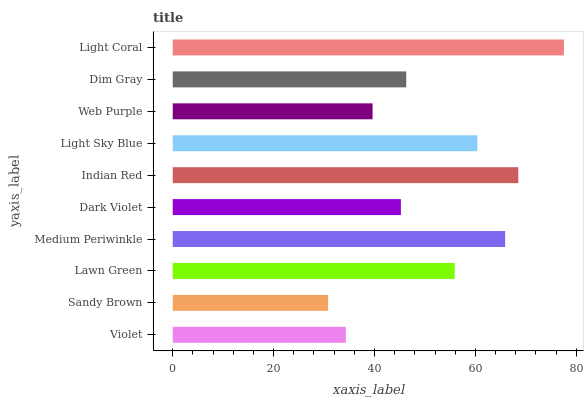Is Sandy Brown the minimum?
Answer yes or no. Yes. Is Light Coral the maximum?
Answer yes or no. Yes. Is Lawn Green the minimum?
Answer yes or no. No. Is Lawn Green the maximum?
Answer yes or no. No. Is Lawn Green greater than Sandy Brown?
Answer yes or no. Yes. Is Sandy Brown less than Lawn Green?
Answer yes or no. Yes. Is Sandy Brown greater than Lawn Green?
Answer yes or no. No. Is Lawn Green less than Sandy Brown?
Answer yes or no. No. Is Lawn Green the high median?
Answer yes or no. Yes. Is Dim Gray the low median?
Answer yes or no. Yes. Is Light Coral the high median?
Answer yes or no. No. Is Medium Periwinkle the low median?
Answer yes or no. No. 